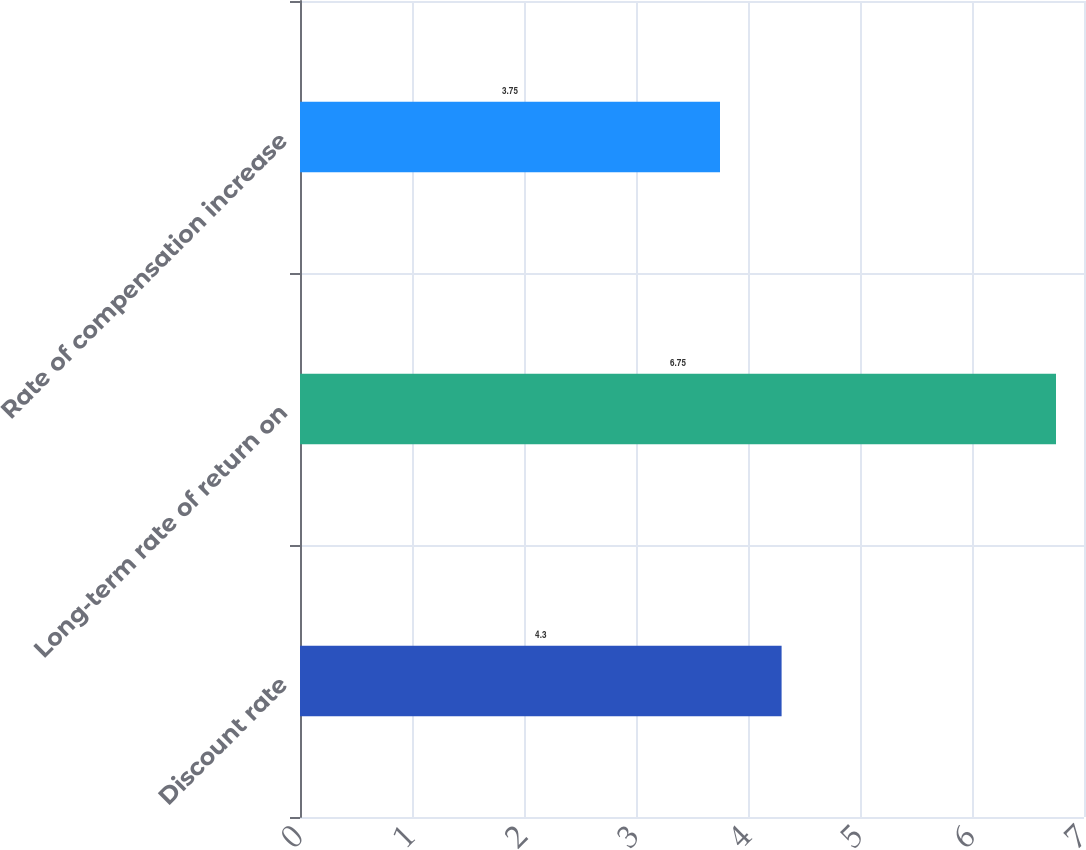Convert chart to OTSL. <chart><loc_0><loc_0><loc_500><loc_500><bar_chart><fcel>Discount rate<fcel>Long-term rate of return on<fcel>Rate of compensation increase<nl><fcel>4.3<fcel>6.75<fcel>3.75<nl></chart> 